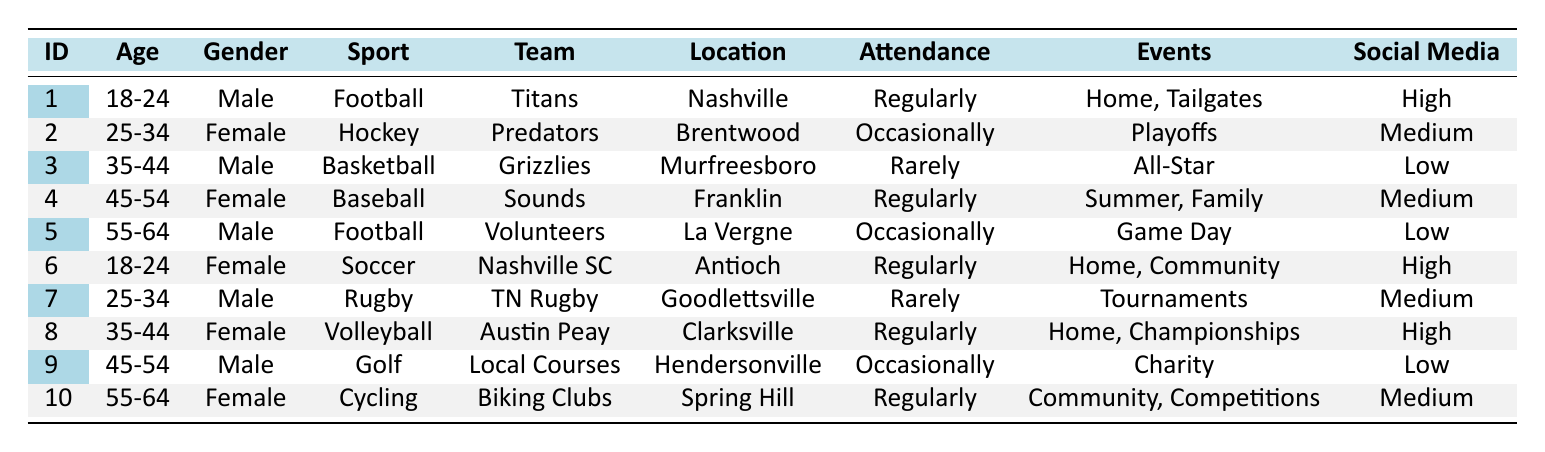What is the favorite sport of the female fan living in Franklin? According to the table, the female fan from Franklin has listed Baseball as her favorite sport.
Answer: Baseball How many regularly attending fans are in the age range of 18-24? The table lists two fans within the 18-24 age range (Males who favor Football and Females who favor Soccer), both of whom attend events regularly.
Answer: 2 Is there a female fan whose favorite sport is Rugby? By checking the table, we find that the only Rugby fan is Male from Goodlettsville, making it false that a female has Rugby as a favorite sport.
Answer: No Which locations have fans that attend events regularly? The fans attending events regularly are from Nashville (Football fan), Antioch (Soccer fan), Franklin (Baseball fan), and Clarksville (Volleyball fan). The summary of these locations is found in the respective entries of those fans in the table.
Answer: Nashville, Antioch, Franklin, Clarksville What is the total attendance frequency count for fans who prefer Football? The data shows two fans like Football; one attends regularly (from Nashville), and the other occasionally (from La Vergne). Thus, the total count for their attendance frequencies is 1 + 1 = 2.
Answer: 2 How many fans from the age range of 35-44 attend events regularly? In the table, we find one fan in the 35-44 age group, a female who lists Volleyball as her favorite sport and attends regularly.
Answer: 1 Can we confirm that the social media usage of fans is distributed equally between high and low among the demographics? Upon examining the table, there are four high usage fans and three low usage fans, indicating uneven distribution of social media usage across demographics.
Answer: No Which team is affiliated with the fan that attends Summer Games and Family Nights? From the table, it is clear that the fan from Franklin, who is a female in the 45-54 age range, has the Nashville Sounds as her team affiliation, attending events like Summer Games and Family Nights.
Answer: Nashville Sounds What fraction of fans prefers Cycling compared to the total number of fans? There is one fan that prefers Cycling out of a total of ten fans listed in the table, which results in a fraction of 1/10 or simplified as 1.
Answer: 1/10 